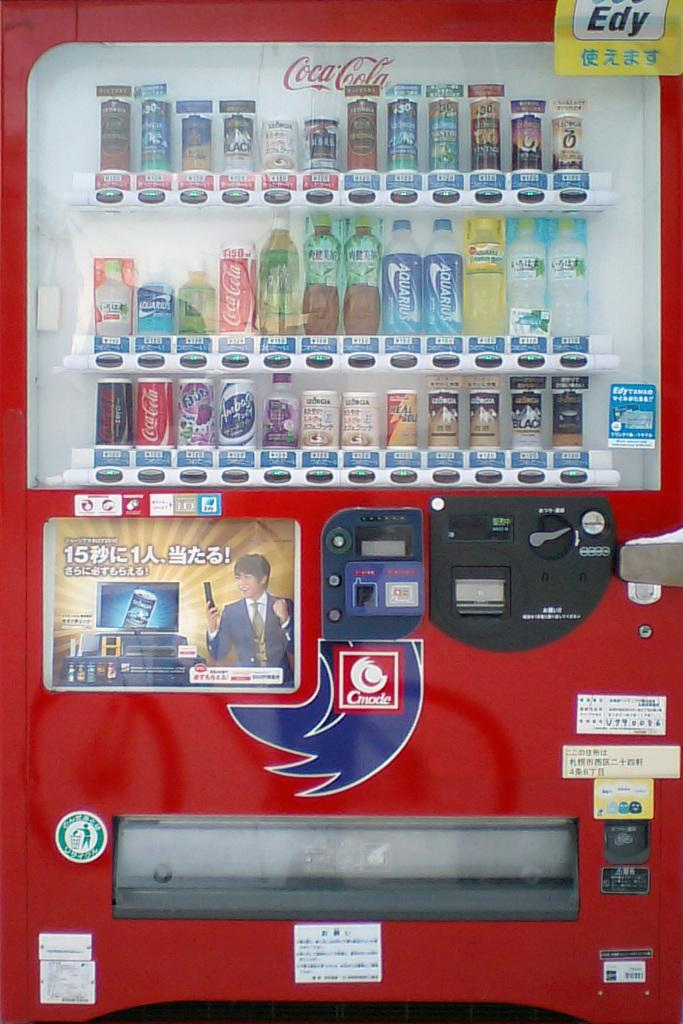<image>
Describe the image concisely. A red vending machine selling Coca-Cola products and Chinese labeled drinks. 